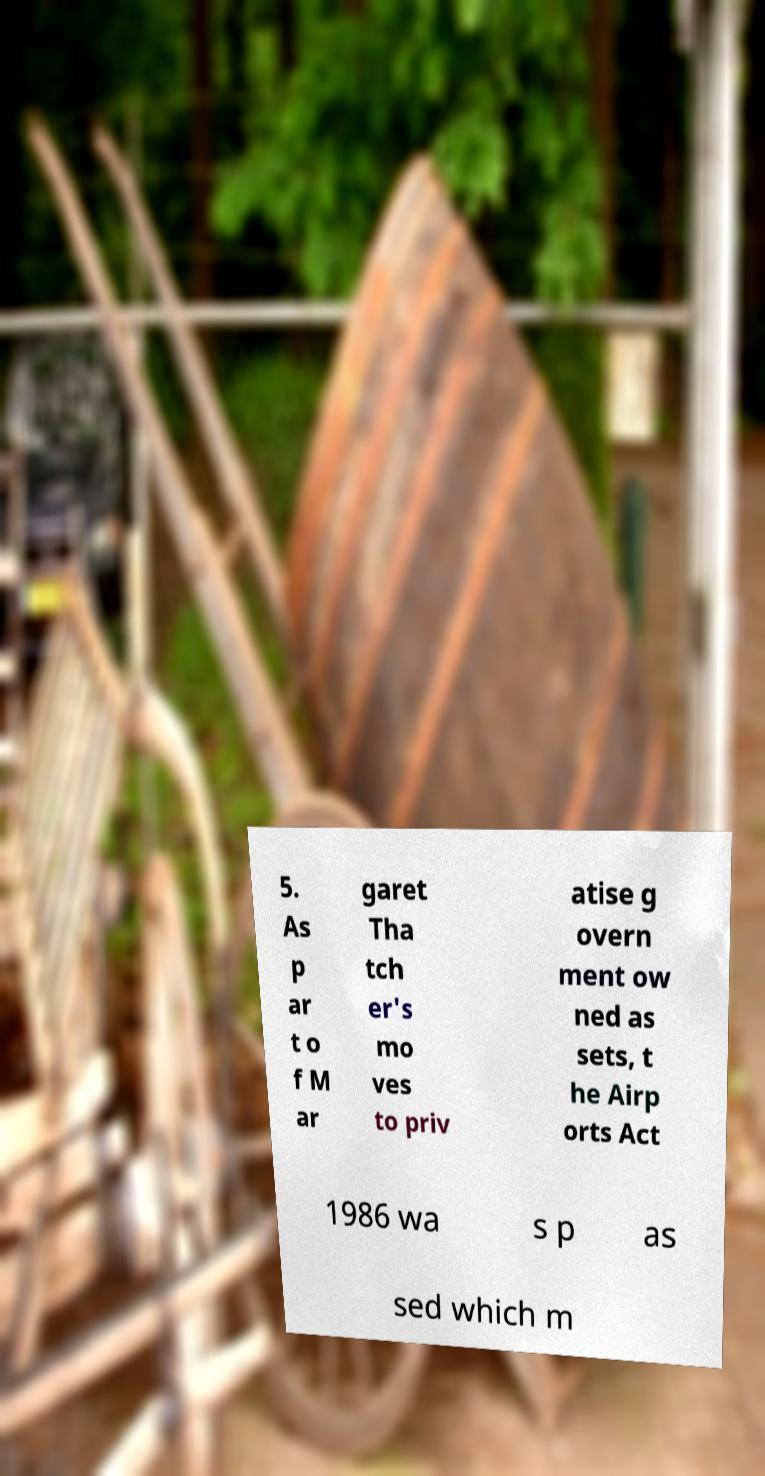For documentation purposes, I need the text within this image transcribed. Could you provide that? 5. As p ar t o f M ar garet Tha tch er's mo ves to priv atise g overn ment ow ned as sets, t he Airp orts Act 1986 wa s p as sed which m 